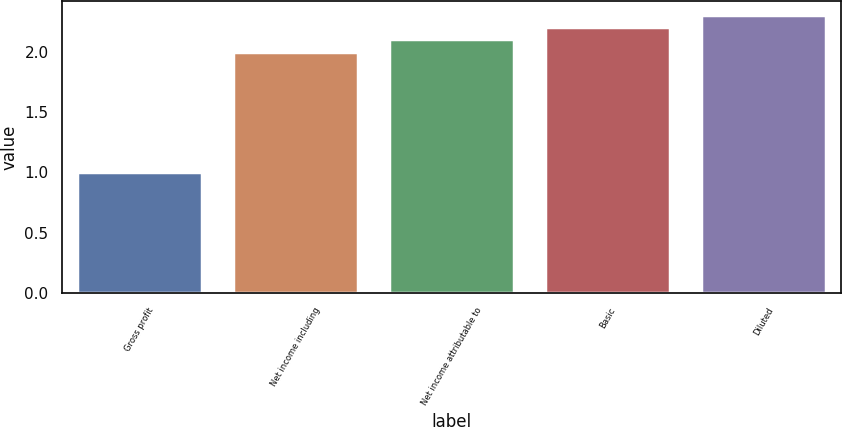<chart> <loc_0><loc_0><loc_500><loc_500><bar_chart><fcel>Gross profit<fcel>Net income including<fcel>Net income attributable to<fcel>Basic<fcel>Diluted<nl><fcel>1<fcel>2<fcel>2.1<fcel>2.2<fcel>2.3<nl></chart> 